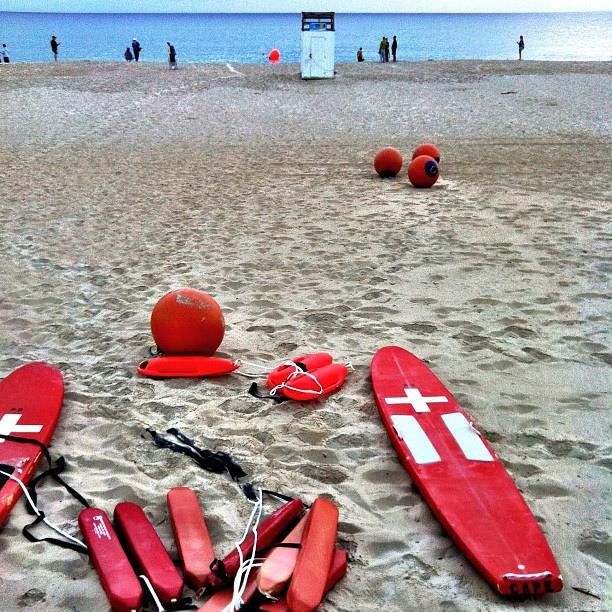Who does this gear on the beach belong to?

Choices:
A) shore waste
B) school kids
C) bikini models
D) lifeguard lifeguard 